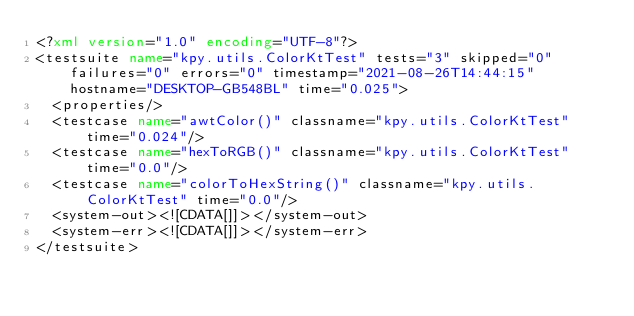<code> <loc_0><loc_0><loc_500><loc_500><_XML_><?xml version="1.0" encoding="UTF-8"?>
<testsuite name="kpy.utils.ColorKtTest" tests="3" skipped="0" failures="0" errors="0" timestamp="2021-08-26T14:44:15" hostname="DESKTOP-GB548BL" time="0.025">
  <properties/>
  <testcase name="awtColor()" classname="kpy.utils.ColorKtTest" time="0.024"/>
  <testcase name="hexToRGB()" classname="kpy.utils.ColorKtTest" time="0.0"/>
  <testcase name="colorToHexString()" classname="kpy.utils.ColorKtTest" time="0.0"/>
  <system-out><![CDATA[]]></system-out>
  <system-err><![CDATA[]]></system-err>
</testsuite>
</code> 